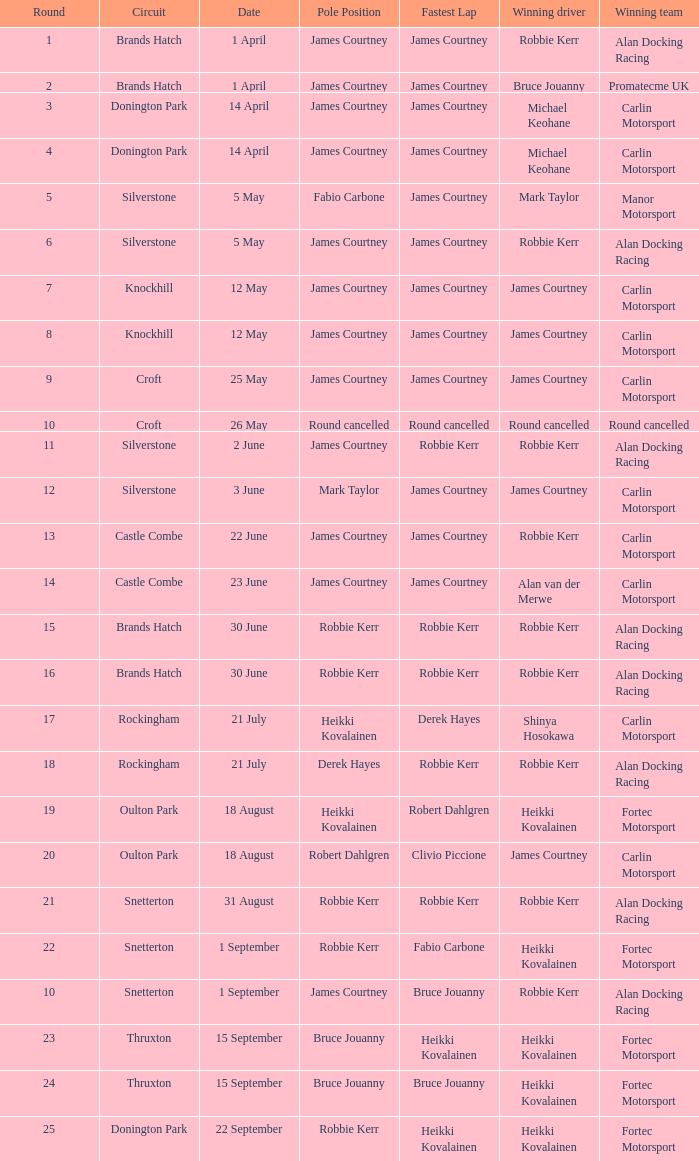How many rounds have Fabio Carbone for fastest lap? 1.0. Could you help me parse every detail presented in this table? {'header': ['Round', 'Circuit', 'Date', 'Pole Position', 'Fastest Lap', 'Winning driver', 'Winning team'], 'rows': [['1', 'Brands Hatch', '1 April', 'James Courtney', 'James Courtney', 'Robbie Kerr', 'Alan Docking Racing'], ['2', 'Brands Hatch', '1 April', 'James Courtney', 'James Courtney', 'Bruce Jouanny', 'Promatecme UK'], ['3', 'Donington Park', '14 April', 'James Courtney', 'James Courtney', 'Michael Keohane', 'Carlin Motorsport'], ['4', 'Donington Park', '14 April', 'James Courtney', 'James Courtney', 'Michael Keohane', 'Carlin Motorsport'], ['5', 'Silverstone', '5 May', 'Fabio Carbone', 'James Courtney', 'Mark Taylor', 'Manor Motorsport'], ['6', 'Silverstone', '5 May', 'James Courtney', 'James Courtney', 'Robbie Kerr', 'Alan Docking Racing'], ['7', 'Knockhill', '12 May', 'James Courtney', 'James Courtney', 'James Courtney', 'Carlin Motorsport'], ['8', 'Knockhill', '12 May', 'James Courtney', 'James Courtney', 'James Courtney', 'Carlin Motorsport'], ['9', 'Croft', '25 May', 'James Courtney', 'James Courtney', 'James Courtney', 'Carlin Motorsport'], ['10', 'Croft', '26 May', 'Round cancelled', 'Round cancelled', 'Round cancelled', 'Round cancelled'], ['11', 'Silverstone', '2 June', 'James Courtney', 'Robbie Kerr', 'Robbie Kerr', 'Alan Docking Racing'], ['12', 'Silverstone', '3 June', 'Mark Taylor', 'James Courtney', 'James Courtney', 'Carlin Motorsport'], ['13', 'Castle Combe', '22 June', 'James Courtney', 'James Courtney', 'Robbie Kerr', 'Carlin Motorsport'], ['14', 'Castle Combe', '23 June', 'James Courtney', 'James Courtney', 'Alan van der Merwe', 'Carlin Motorsport'], ['15', 'Brands Hatch', '30 June', 'Robbie Kerr', 'Robbie Kerr', 'Robbie Kerr', 'Alan Docking Racing'], ['16', 'Brands Hatch', '30 June', 'Robbie Kerr', 'Robbie Kerr', 'Robbie Kerr', 'Alan Docking Racing'], ['17', 'Rockingham', '21 July', 'Heikki Kovalainen', 'Derek Hayes', 'Shinya Hosokawa', 'Carlin Motorsport'], ['18', 'Rockingham', '21 July', 'Derek Hayes', 'Robbie Kerr', 'Robbie Kerr', 'Alan Docking Racing'], ['19', 'Oulton Park', '18 August', 'Heikki Kovalainen', 'Robert Dahlgren', 'Heikki Kovalainen', 'Fortec Motorsport'], ['20', 'Oulton Park', '18 August', 'Robert Dahlgren', 'Clivio Piccione', 'James Courtney', 'Carlin Motorsport'], ['21', 'Snetterton', '31 August', 'Robbie Kerr', 'Robbie Kerr', 'Robbie Kerr', 'Alan Docking Racing'], ['22', 'Snetterton', '1 September', 'Robbie Kerr', 'Fabio Carbone', 'Heikki Kovalainen', 'Fortec Motorsport'], ['10', 'Snetterton', '1 September', 'James Courtney', 'Bruce Jouanny', 'Robbie Kerr', 'Alan Docking Racing'], ['23', 'Thruxton', '15 September', 'Bruce Jouanny', 'Heikki Kovalainen', 'Heikki Kovalainen', 'Fortec Motorsport'], ['24', 'Thruxton', '15 September', 'Bruce Jouanny', 'Bruce Jouanny', 'Heikki Kovalainen', 'Fortec Motorsport'], ['25', 'Donington Park', '22 September', 'Robbie Kerr', 'Heikki Kovalainen', 'Heikki Kovalainen', 'Fortec Motorsport']]} 